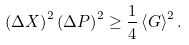Convert formula to latex. <formula><loc_0><loc_0><loc_500><loc_500>\left ( \Delta X \right ) ^ { 2 } \left ( \Delta P \right ) ^ { 2 } \geq \frac { 1 } { 4 } \left \langle G \right \rangle ^ { 2 } .</formula> 